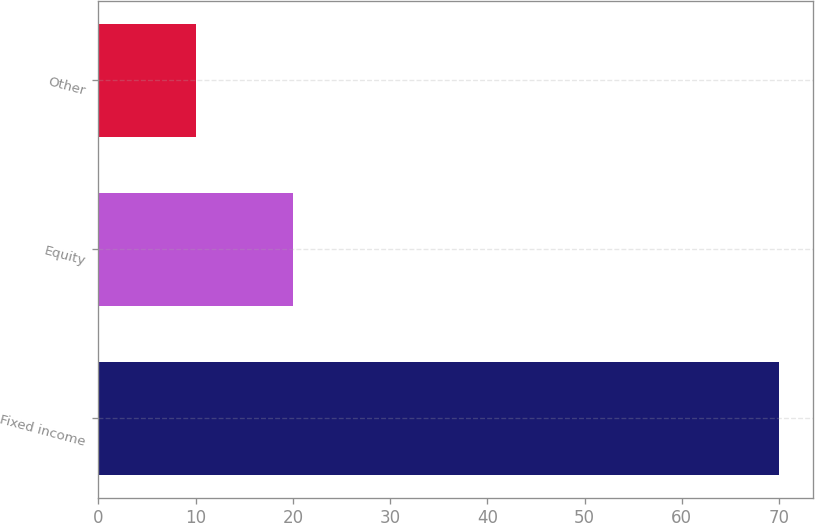<chart> <loc_0><loc_0><loc_500><loc_500><bar_chart><fcel>Fixed income<fcel>Equity<fcel>Other<nl><fcel>70<fcel>20<fcel>10<nl></chart> 